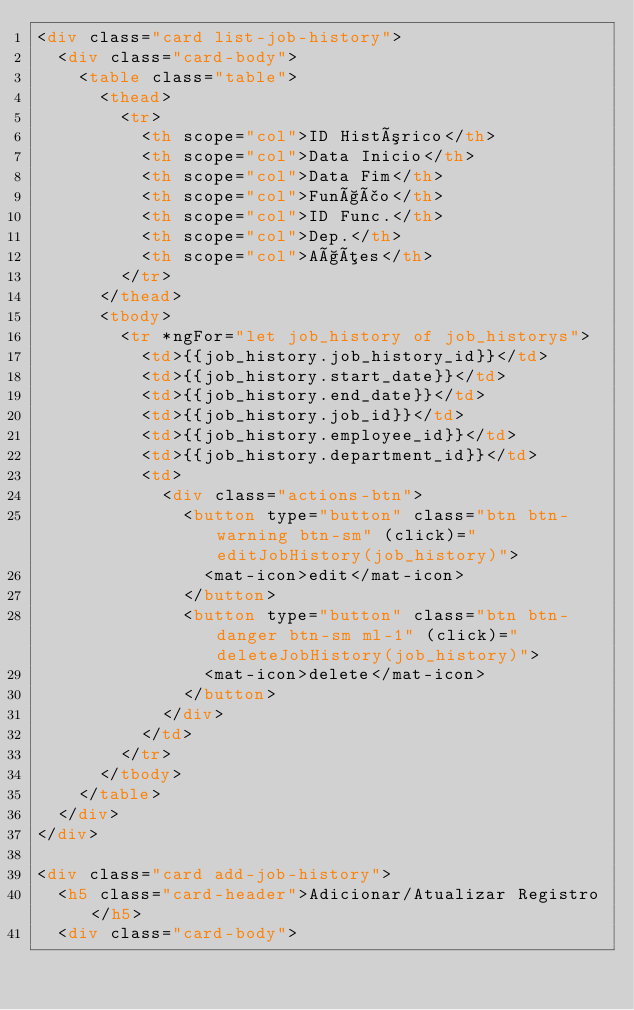<code> <loc_0><loc_0><loc_500><loc_500><_HTML_><div class="card list-job-history">
  <div class="card-body">
    <table class="table">
      <thead>
        <tr>
          <th scope="col">ID Histórico</th>
          <th scope="col">Data Inicio</th>
          <th scope="col">Data Fim</th>
          <th scope="col">Função</th>
          <th scope="col">ID Func.</th>
          <th scope="col">Dep.</th>
          <th scope="col">Ações</th>
        </tr>
      </thead>
      <tbody>
        <tr *ngFor="let job_history of job_historys">
          <td>{{job_history.job_history_id}}</td>
          <td>{{job_history.start_date}}</td>
          <td>{{job_history.end_date}}</td>
          <td>{{job_history.job_id}}</td>
          <td>{{job_history.employee_id}}</td>
          <td>{{job_history.department_id}}</td>
          <td>
            <div class="actions-btn">
              <button type="button" class="btn btn-warning btn-sm" (click)="editJobHistory(job_history)">
                <mat-icon>edit</mat-icon>
              </button>
              <button type="button" class="btn btn-danger btn-sm ml-1" (click)="deleteJobHistory(job_history)">
                <mat-icon>delete</mat-icon>
              </button>
            </div>
          </td>
        </tr>
      </tbody>
    </table>
  </div>
</div>

<div class="card add-job-history">
  <h5 class="card-header">Adicionar/Atualizar Registro</h5>
  <div class="card-body"></code> 